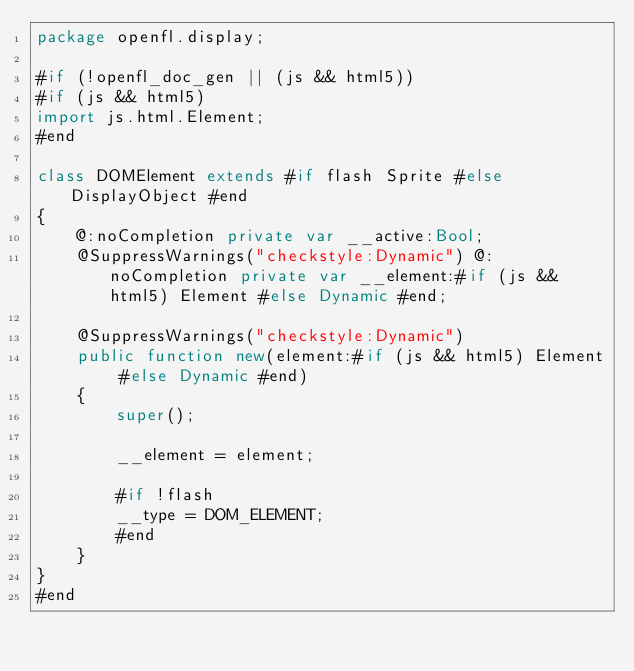<code> <loc_0><loc_0><loc_500><loc_500><_Haxe_>package openfl.display;

#if (!openfl_doc_gen || (js && html5))
#if (js && html5)
import js.html.Element;
#end

class DOMElement extends #if flash Sprite #else DisplayObject #end
{
	@:noCompletion private var __active:Bool;
	@SuppressWarnings("checkstyle:Dynamic") @:noCompletion private var __element:#if (js && html5) Element #else Dynamic #end;

	@SuppressWarnings("checkstyle:Dynamic")
	public function new(element:#if (js && html5) Element #else Dynamic #end)
	{
		super();

		__element = element;

		#if !flash
		__type = DOM_ELEMENT;
		#end
	}
}
#end
</code> 